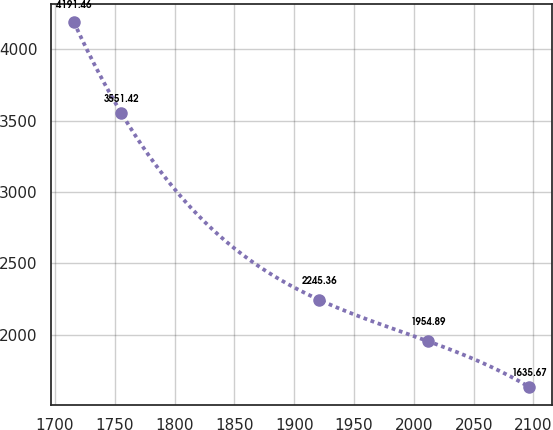Convert chart. <chart><loc_0><loc_0><loc_500><loc_500><line_chart><ecel><fcel>Unnamed: 1<nl><fcel>1715.73<fcel>4191.46<nl><fcel>1755.59<fcel>3551.42<nl><fcel>1920.91<fcel>2245.36<nl><fcel>2012<fcel>1954.89<nl><fcel>2096.34<fcel>1635.67<nl></chart> 